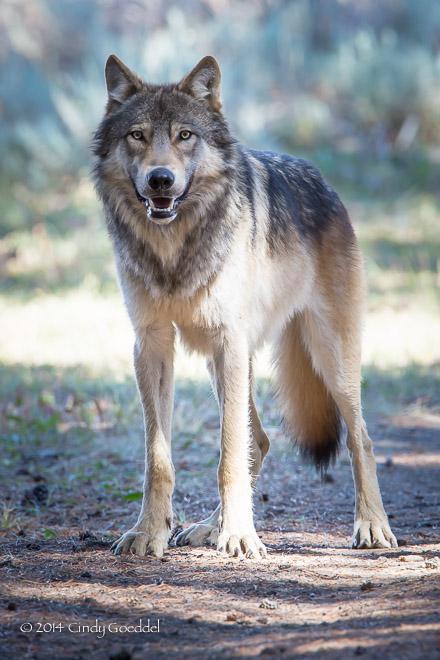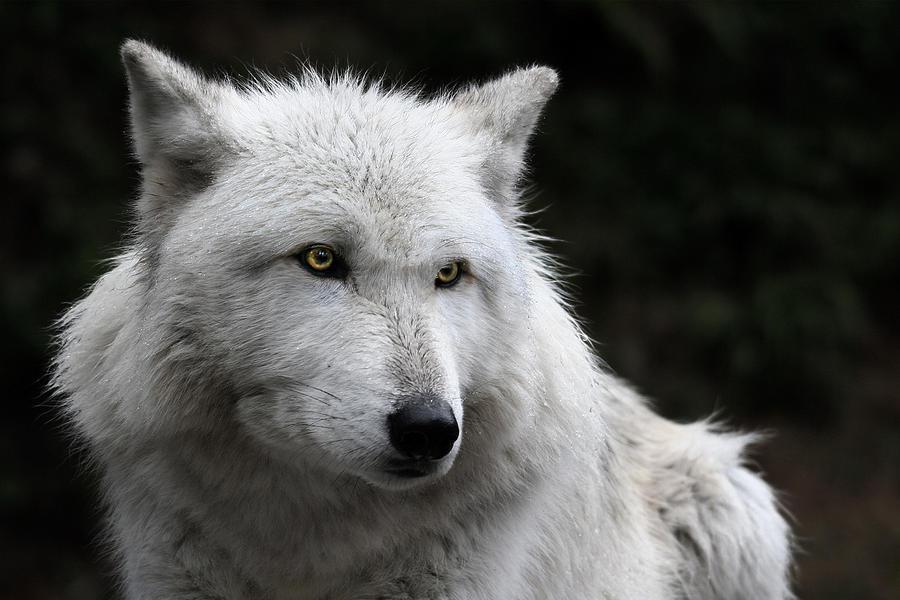The first image is the image on the left, the second image is the image on the right. Analyze the images presented: Is the assertion "One image shows a wolf in a snowy scene." valid? Answer yes or no. No. 